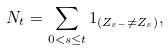Convert formula to latex. <formula><loc_0><loc_0><loc_500><loc_500>N _ { t } & = \sum _ { 0 < s \leq t } 1 _ { ( Z _ { s - } \neq Z _ { s } ) } ,</formula> 